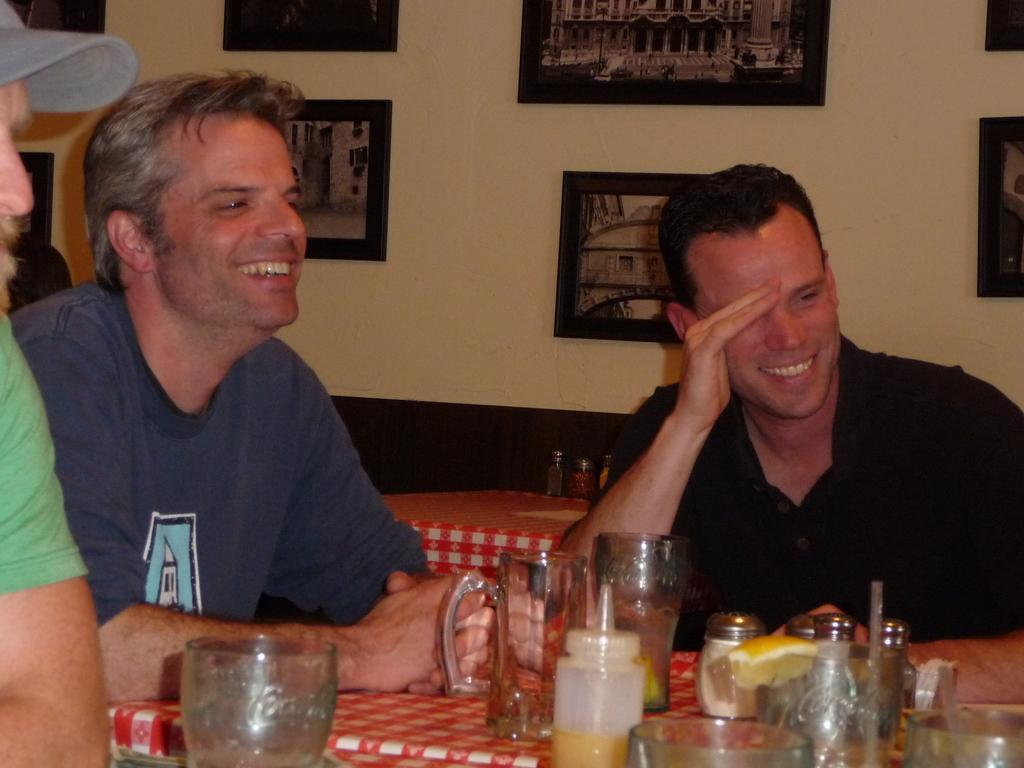Could you give a brief overview of what you see in this image? In this image we can see persons sitting at the table. On the table we can see glass tumblers, beverage bottles and straw. In the background we can see table, sofa, photo frames and wall. 